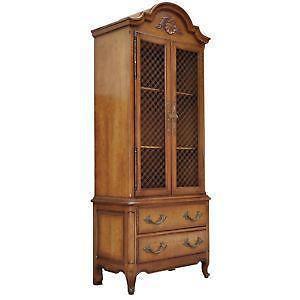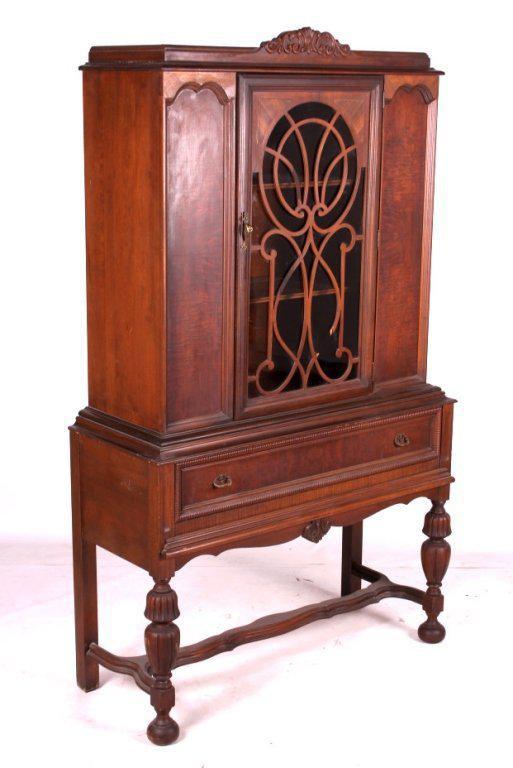The first image is the image on the left, the second image is the image on the right. Assess this claim about the two images: "There are dishes in one of the cabinets.". Correct or not? Answer yes or no. No. 